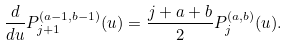Convert formula to latex. <formula><loc_0><loc_0><loc_500><loc_500>\frac { d } { d u } P _ { j + 1 } ^ { ( a - 1 , b - 1 ) } ( u ) = \frac { j + a + b } { 2 } P _ { j } ^ { ( a , b ) } ( u ) .</formula> 